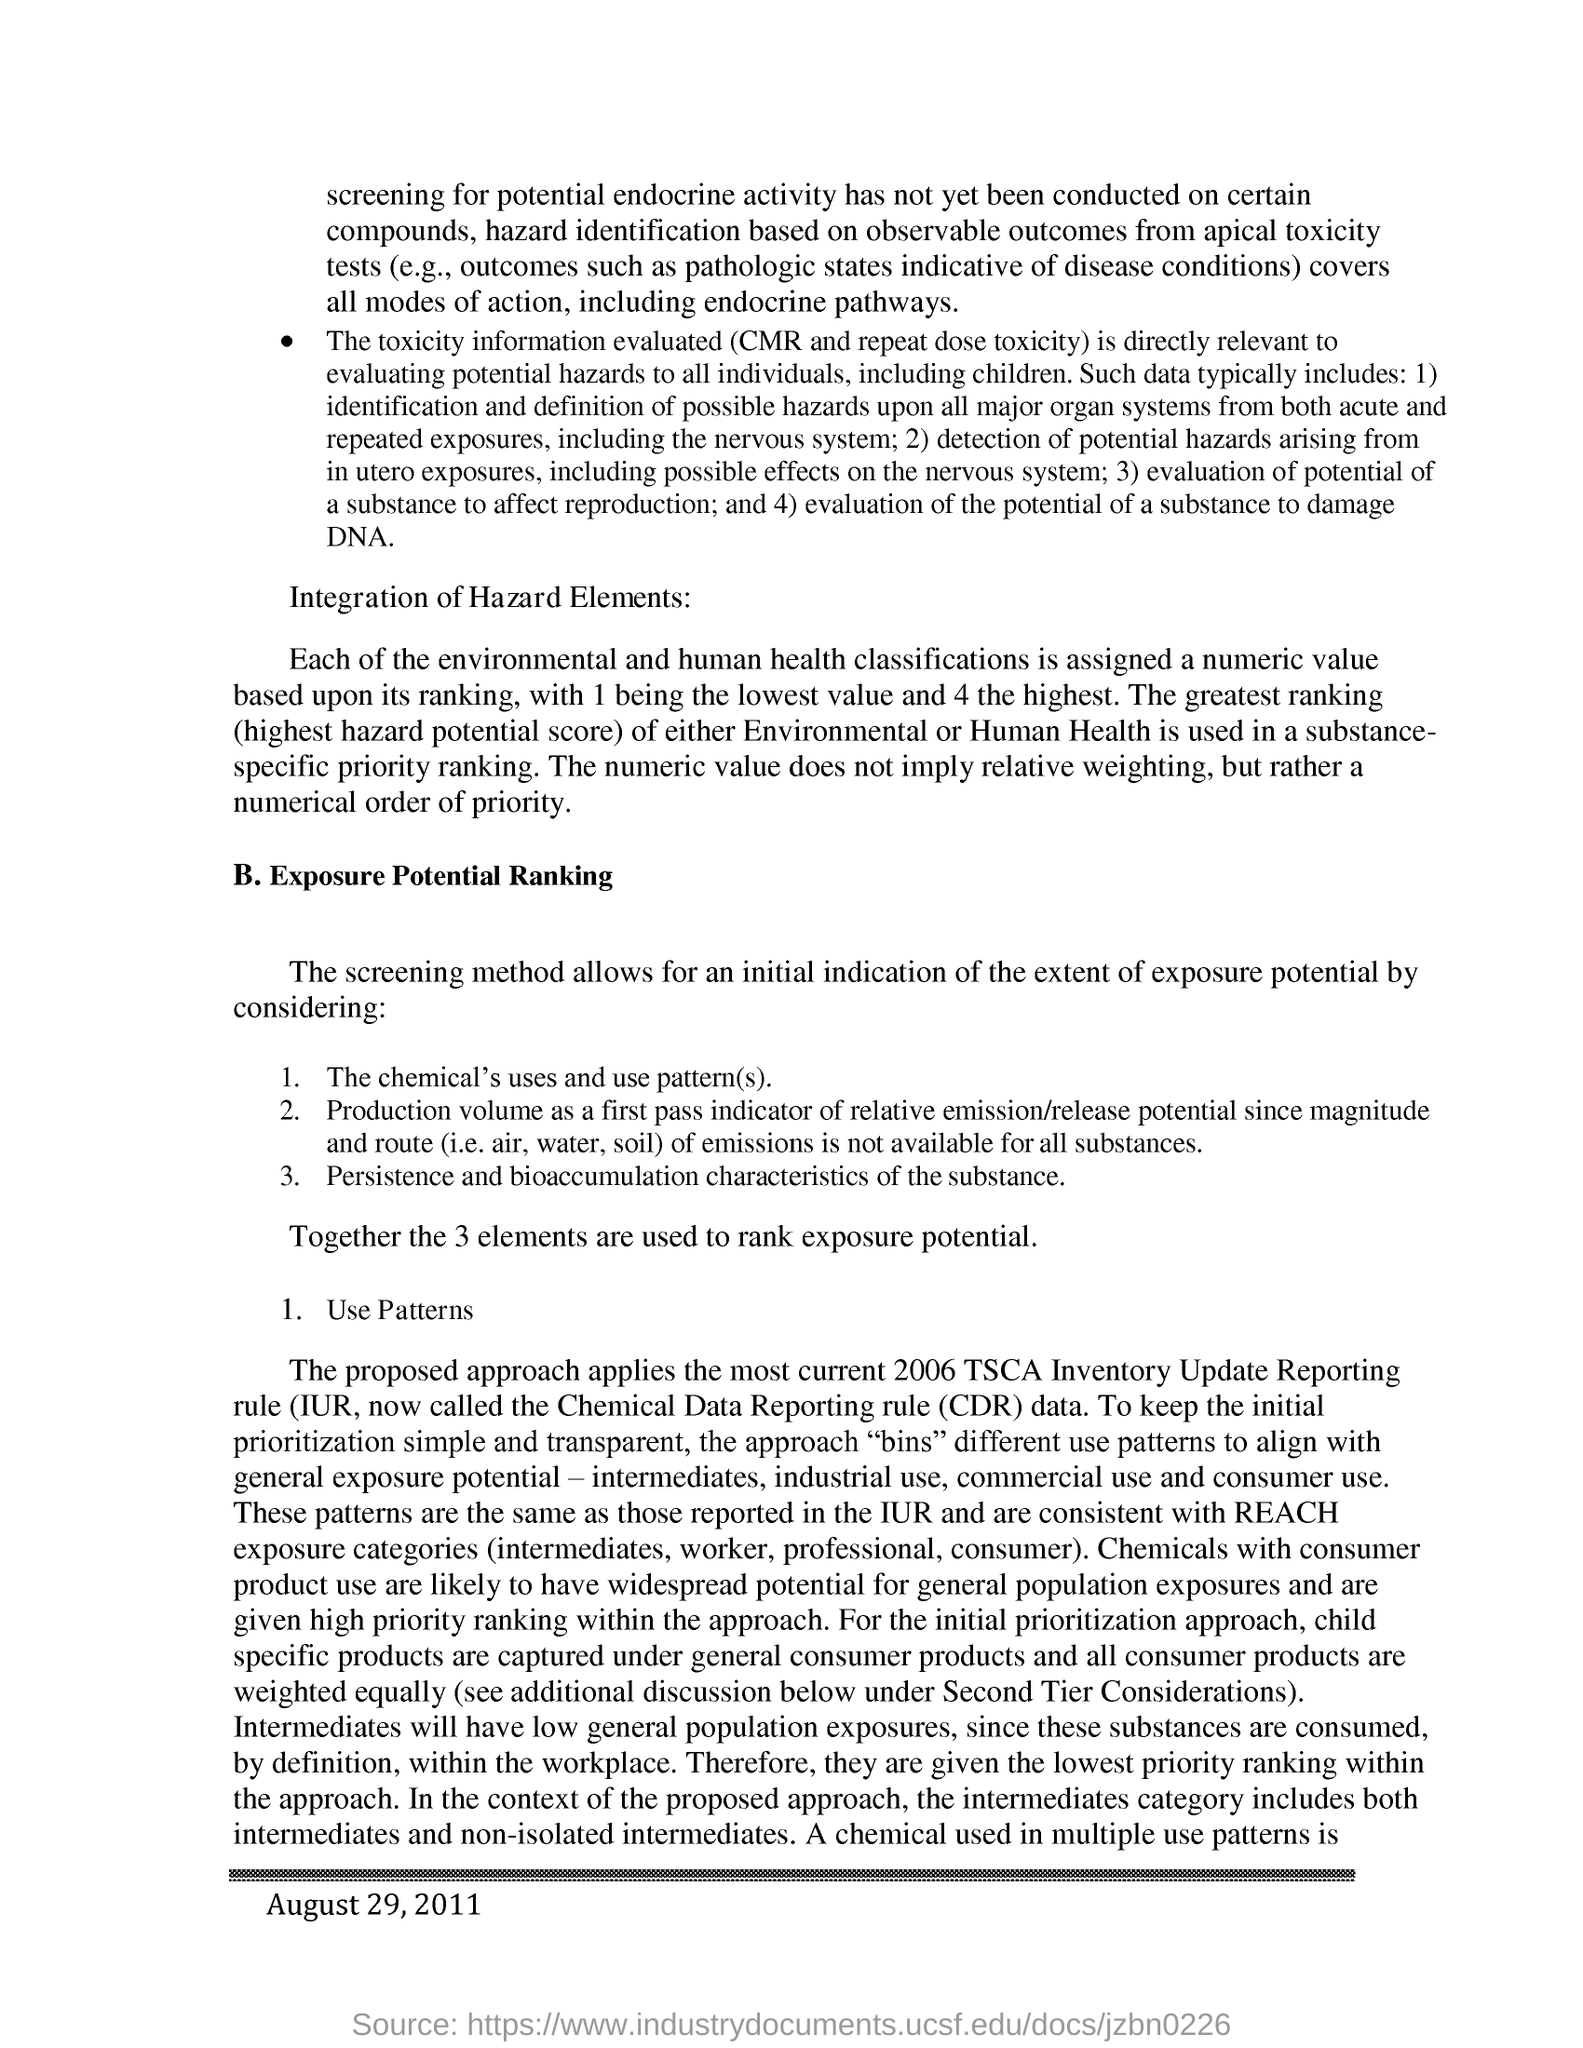Outline some significant characteristics in this image. The heading for point B is 'Exposure Potential Ranking.' The total number of elements used to determine rank, exposure, and potential is 3. The date mentioned at the bottom of the text is August 29, 2011. The proposed approach most closely aligns with the reporting requirements of the TSCA Inventory Update Reporting rule for the year 2006. 